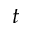<formula> <loc_0><loc_0><loc_500><loc_500>t</formula> 